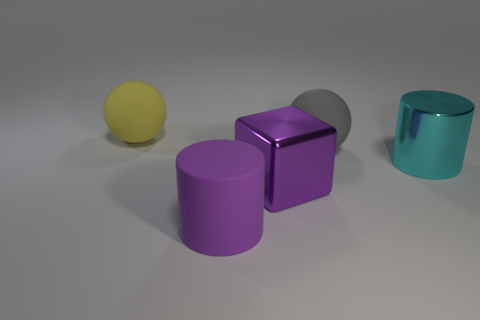Add 2 blue cylinders. How many objects exist? 7 Subtract all blocks. How many objects are left? 4 Subtract 0 brown cubes. How many objects are left? 5 Subtract all green rubber balls. Subtract all large cyan metal objects. How many objects are left? 4 Add 5 gray matte balls. How many gray matte balls are left? 6 Add 3 yellow rubber spheres. How many yellow rubber spheres exist? 4 